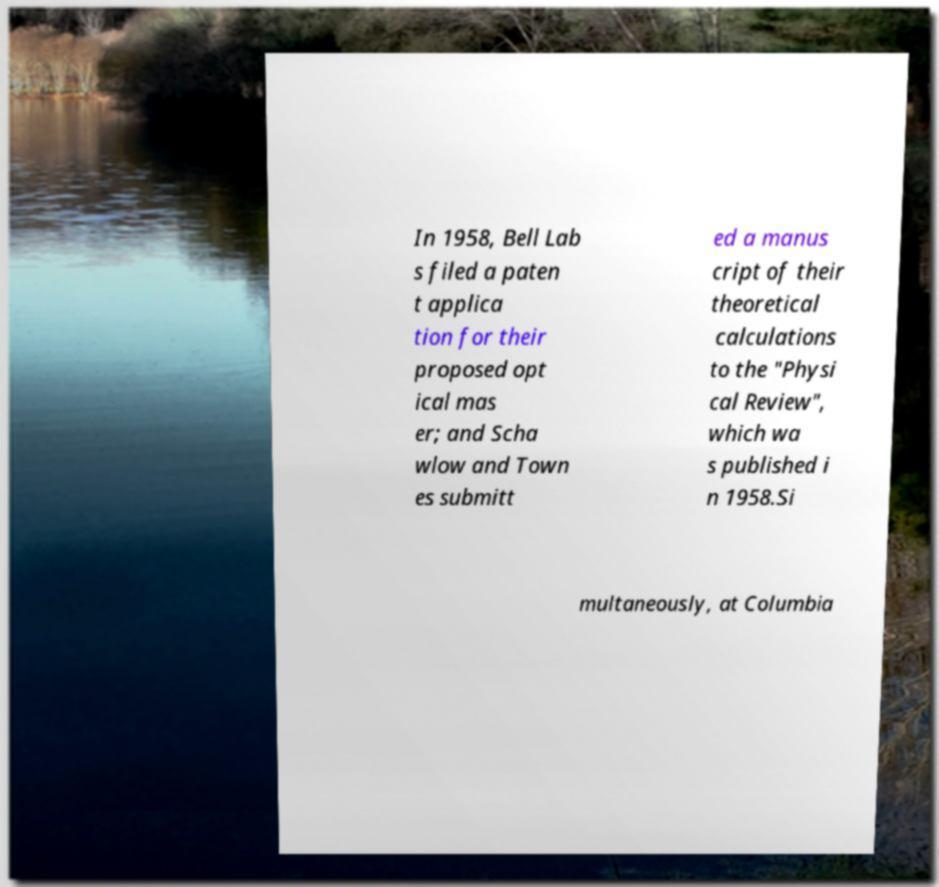Could you assist in decoding the text presented in this image and type it out clearly? In 1958, Bell Lab s filed a paten t applica tion for their proposed opt ical mas er; and Scha wlow and Town es submitt ed a manus cript of their theoretical calculations to the "Physi cal Review", which wa s published i n 1958.Si multaneously, at Columbia 